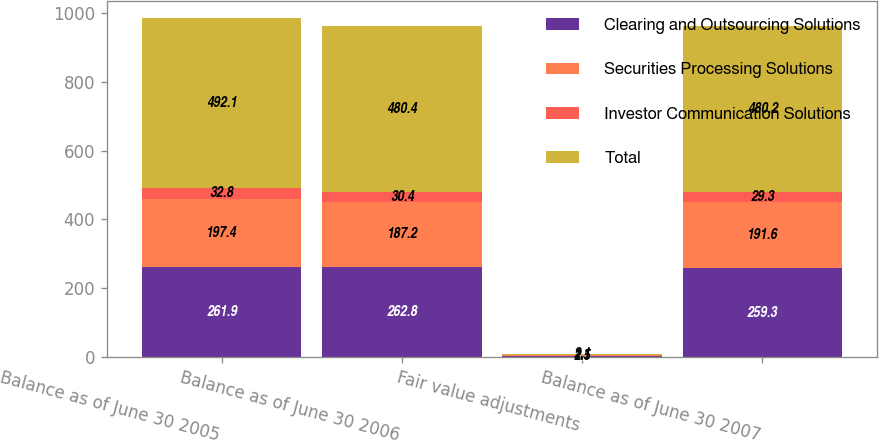<chart> <loc_0><loc_0><loc_500><loc_500><stacked_bar_chart><ecel><fcel>Balance as of June 30 2005<fcel>Balance as of June 30 2006<fcel>Fair value adjustments<fcel>Balance as of June 30 2007<nl><fcel>Clearing and Outsourcing Solutions<fcel>261.9<fcel>262.8<fcel>3.5<fcel>259.3<nl><fcel>Securities Processing Solutions<fcel>197.4<fcel>187.2<fcel>2.5<fcel>191.6<nl><fcel>Investor Communication Solutions<fcel>32.8<fcel>30.4<fcel>1.1<fcel>29.3<nl><fcel>Total<fcel>492.1<fcel>480.4<fcel>2.1<fcel>480.2<nl></chart> 